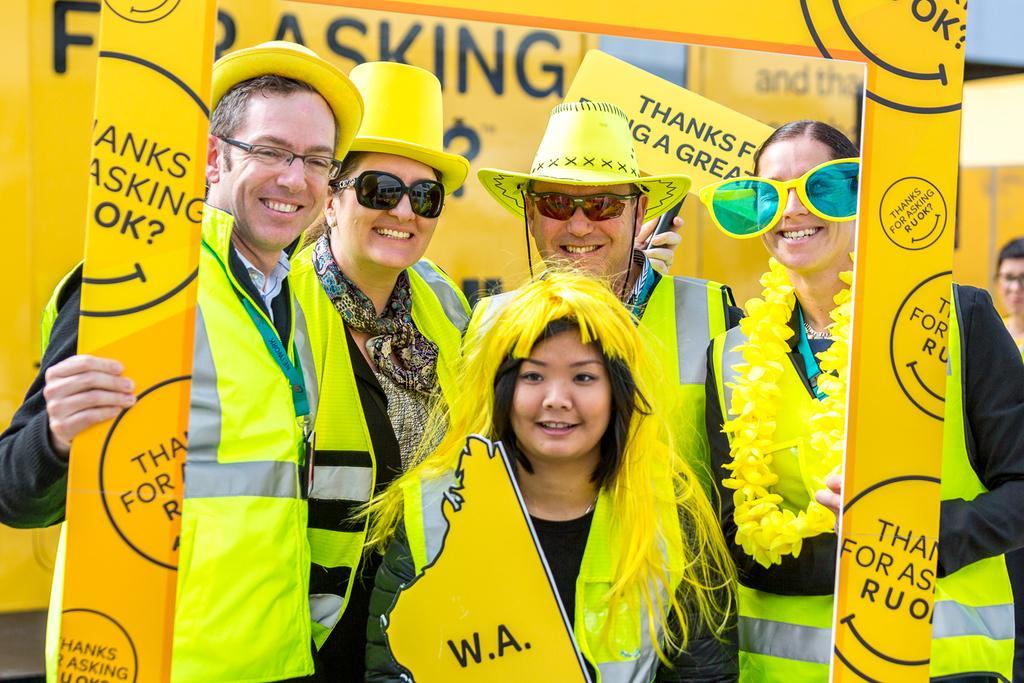Describe this image in one or two sentences. In this picture I can observe five members. Three of them are men and two of them are women. All of them are smiling. They are wearing green color coats. Four of them are wearing spectacles. One of them is holding yellow color frame in his hand. 